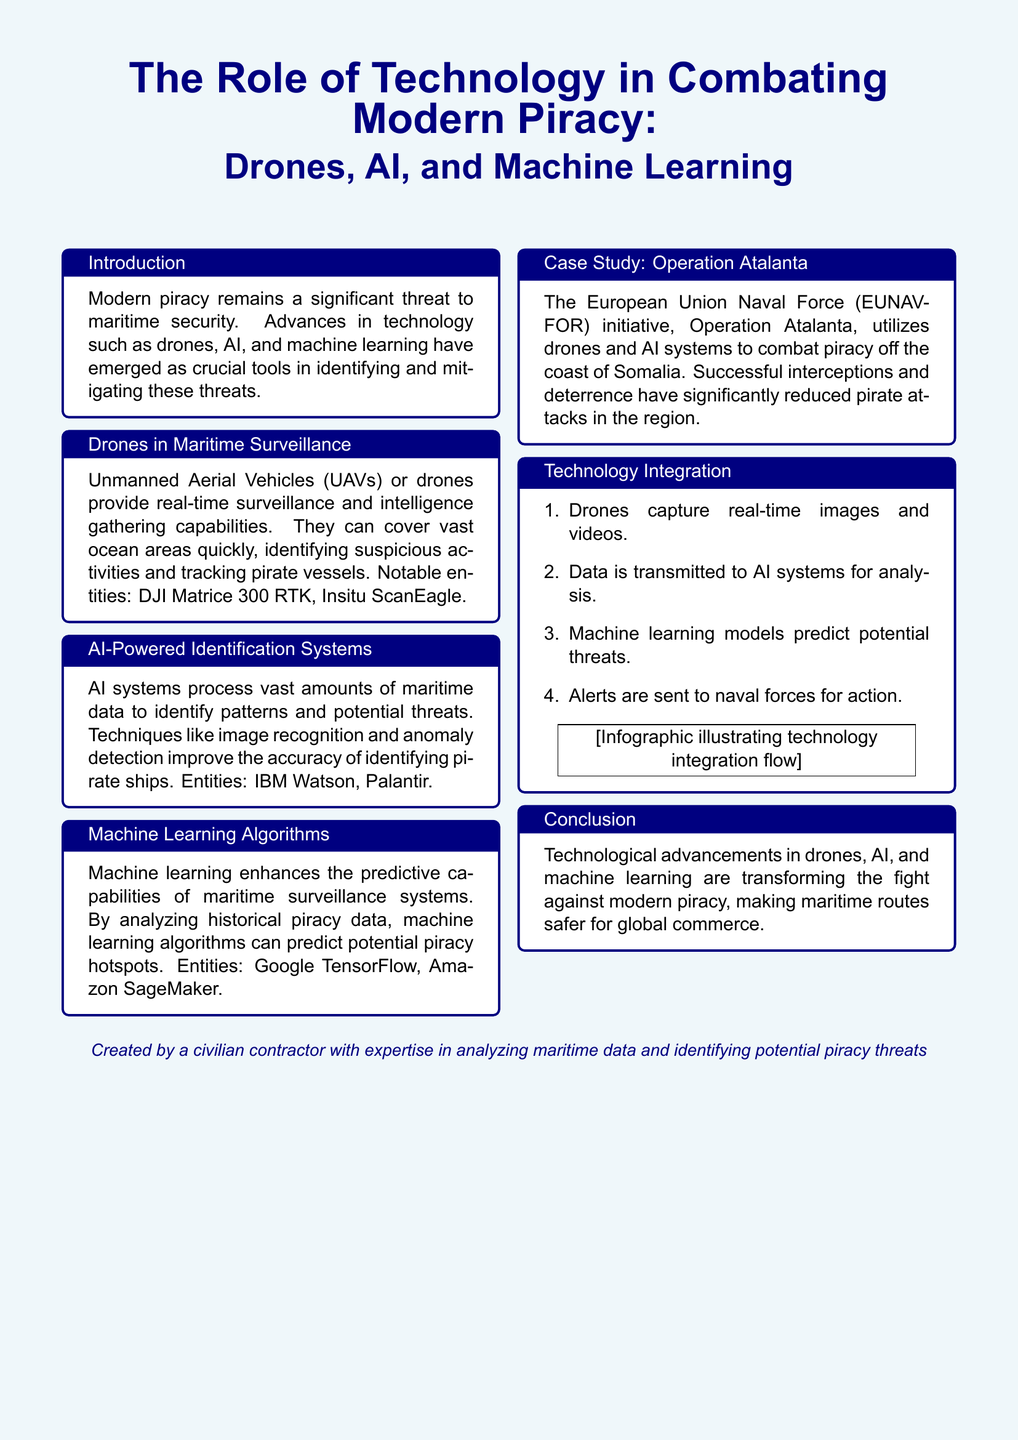What is the title of the flyer? The title of the flyer is prominently displayed at the top, summarizing its focus on technological advancements in piracy combat.
Answer: The Role of Technology in Combating Modern Piracy: Drones, AI, and Machine Learning Which technology is described as providing real-time surveillance? The document discusses the capabilities of Unmanned Aerial Vehicles (UAVs) or drones for surveillance.
Answer: Drones What notable entity is mentioned for drones? The flyer lists specific drone models to exemplify the technology being used for maritime surveillance.
Answer: DJI Matrice 300 RTK What AI system is used for processing maritime data? The text identifies specific AI technologies that aid in recognizing patterns in maritime data.
Answer: IBM Watson What does machine learning enhance in maritime surveillance? The document addresses the predictive capabilities that machine learning brings to monitoring and analyzing past piracy incidents.
Answer: Predictive capabilities Which operation utilizes drones and AI systems to combat piracy? A specific case study is highlighted in the flyer that showcases real-world applications of the discussed technologies.
Answer: Operation Atalanta How many steps are outlined in the technology integration process? The flyer presents an organized list detailing the steps involved in integrating these technologies to combat piracy.
Answer: Four What is the overall conclusion about technological advancements mentioned in the flyer? The conclusion summarizes the overall impact of technology on maritime safety and piracy deterrence.
Answer: Making maritime routes safer for global commerce 